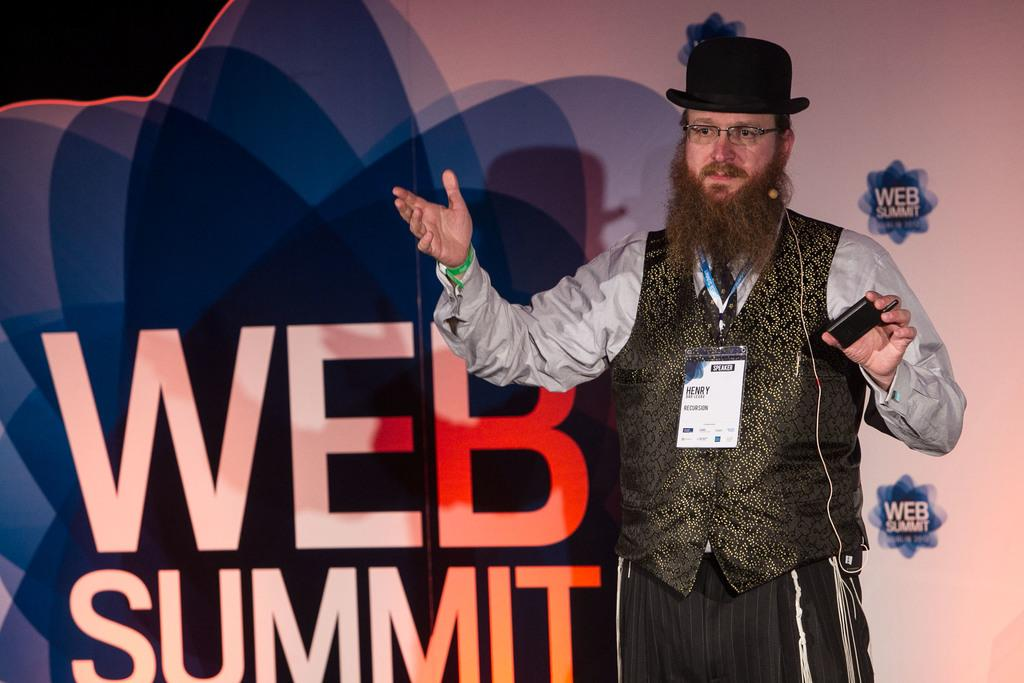What can be seen on the right side of the image? There is a person standing to the right side of the image. What is the person wearing on their head? The person is wearing a cap. What is present in the background of the image? There is a banner with text in the background of the image. How many children are playing with the vase in the image? There are no children or vase present in the image. 